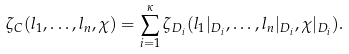<formula> <loc_0><loc_0><loc_500><loc_500>\zeta _ { C } ( l _ { 1 } , \dots , l _ { n } , \chi ) = \sum _ { i = 1 } ^ { \kappa } \zeta _ { D _ { i } } ( l _ { 1 } | _ { D _ { i } } , \dots , l _ { n } | _ { D _ { i } } , \chi | _ { D _ { i } } ) .</formula> 